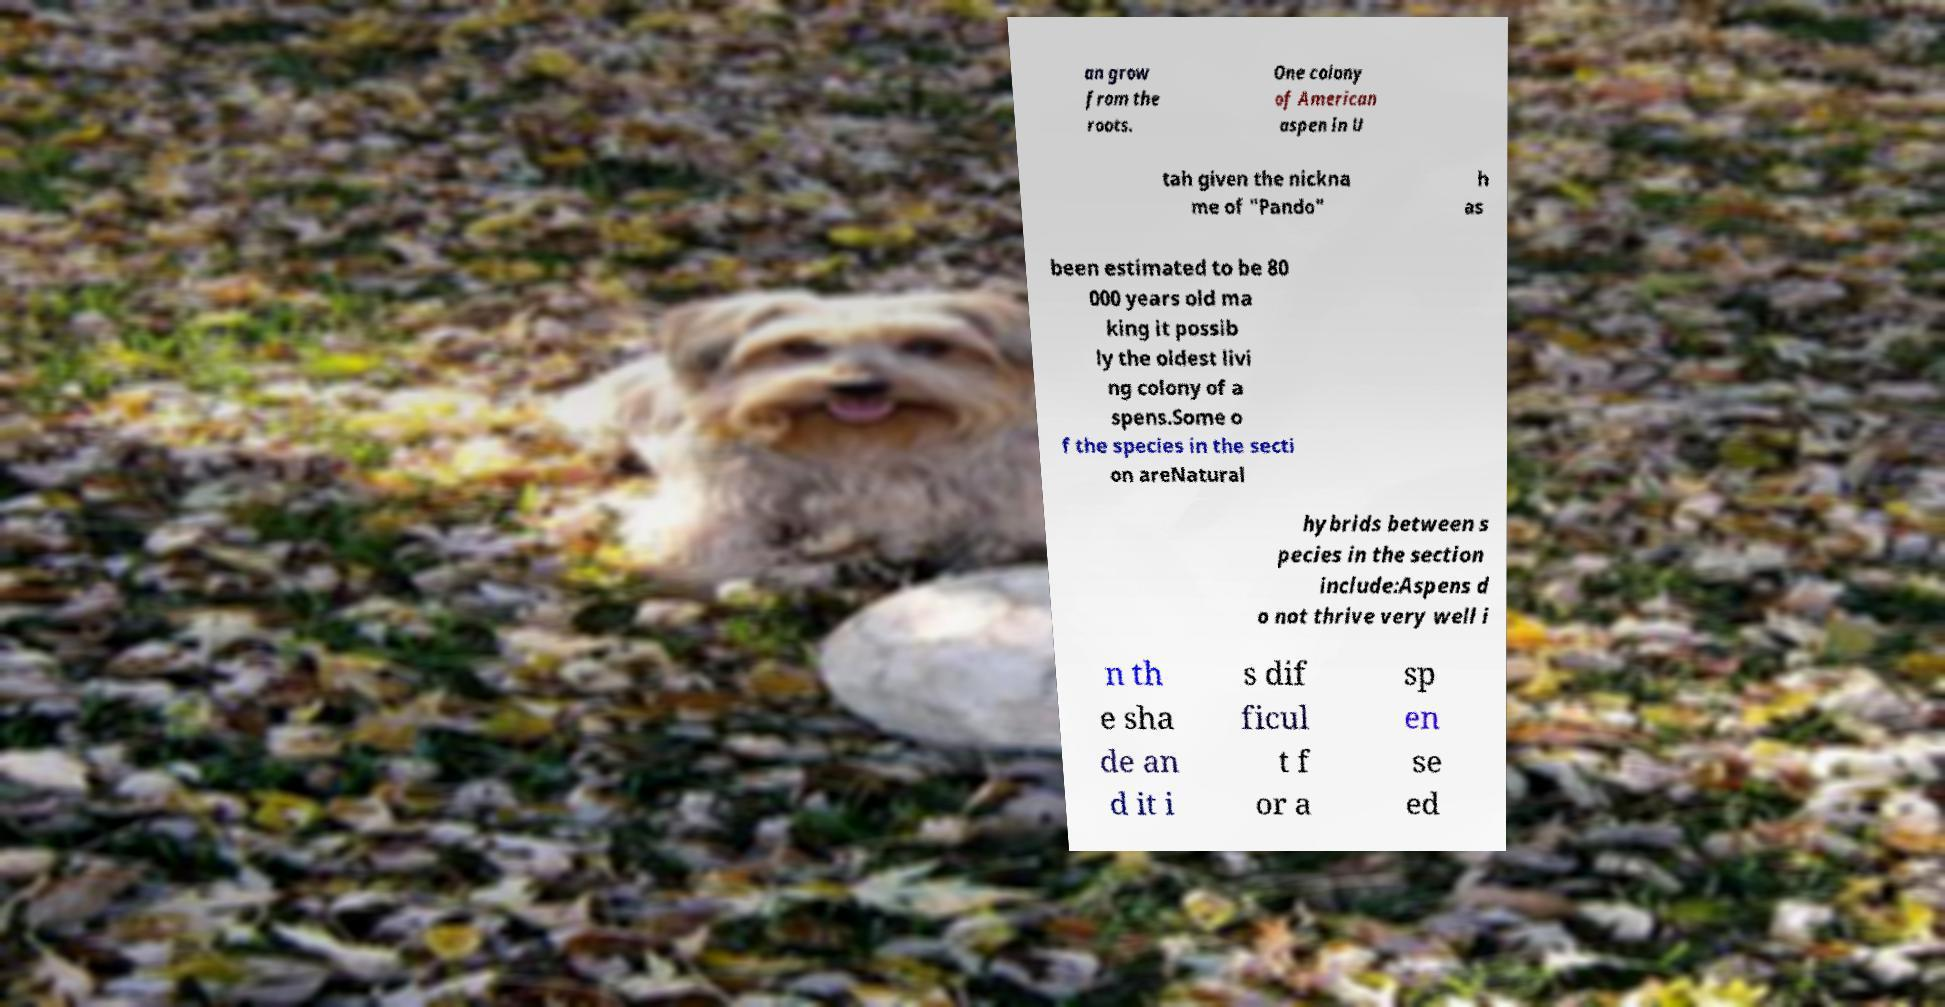Can you accurately transcribe the text from the provided image for me? an grow from the roots. One colony of American aspen in U tah given the nickna me of "Pando" h as been estimated to be 80 000 years old ma king it possib ly the oldest livi ng colony of a spens.Some o f the species in the secti on areNatural hybrids between s pecies in the section include:Aspens d o not thrive very well i n th e sha de an d it i s dif ficul t f or a sp en se ed 